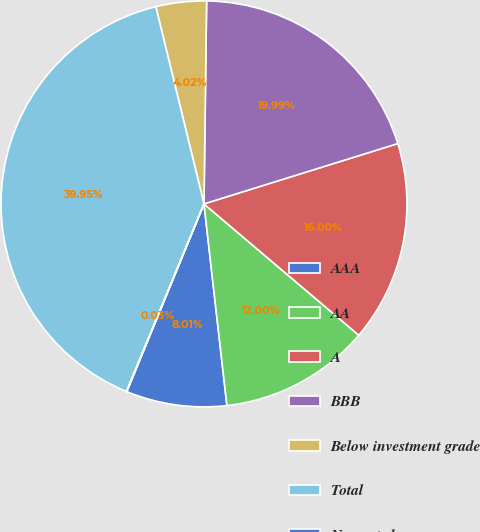Convert chart. <chart><loc_0><loc_0><loc_500><loc_500><pie_chart><fcel>AAA<fcel>AA<fcel>A<fcel>BBB<fcel>Below investment grade<fcel>Total<fcel>Non-rated<nl><fcel>8.01%<fcel>12.0%<fcel>16.0%<fcel>19.99%<fcel>4.02%<fcel>39.95%<fcel>0.03%<nl></chart> 